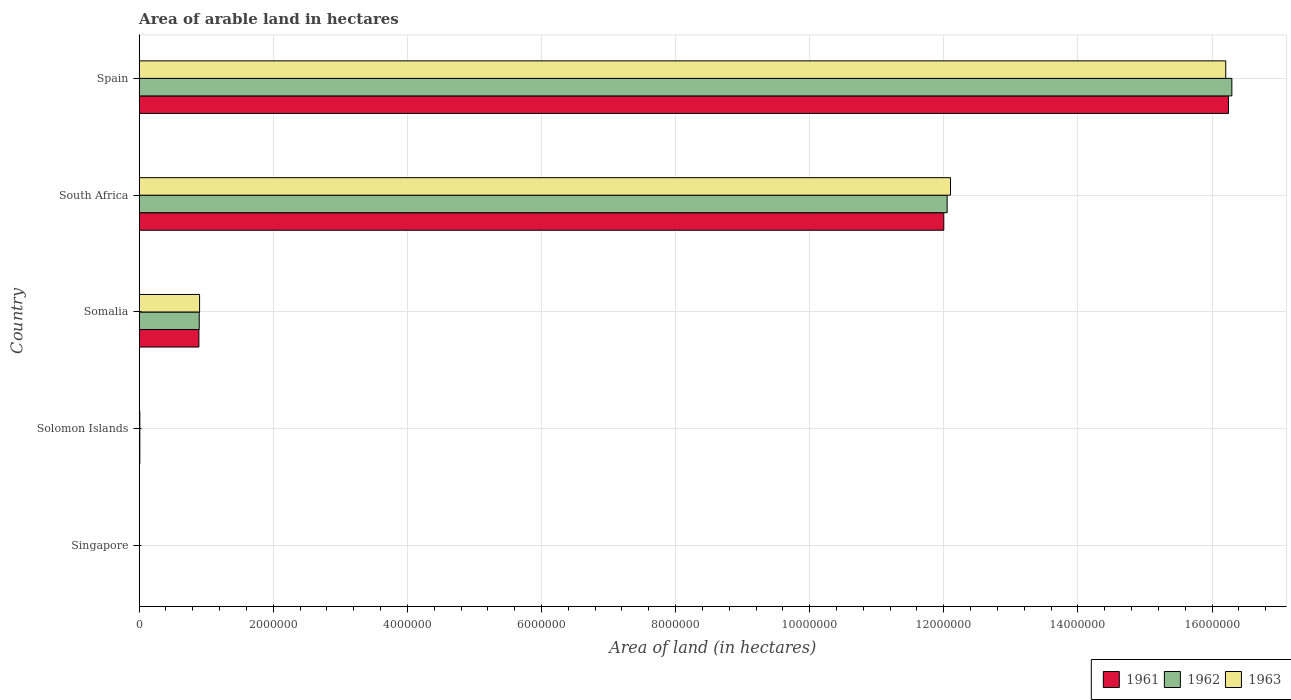How many different coloured bars are there?
Give a very brief answer. 3. How many groups of bars are there?
Your answer should be compact. 5. Are the number of bars on each tick of the Y-axis equal?
Offer a terse response. Yes. How many bars are there on the 3rd tick from the bottom?
Your answer should be very brief. 3. What is the label of the 3rd group of bars from the top?
Make the answer very short. Somalia. In how many cases, is the number of bars for a given country not equal to the number of legend labels?
Keep it short and to the point. 0. What is the total arable land in 1963 in South Africa?
Give a very brief answer. 1.21e+07. Across all countries, what is the maximum total arable land in 1962?
Keep it short and to the point. 1.63e+07. Across all countries, what is the minimum total arable land in 1961?
Offer a terse response. 3000. In which country was the total arable land in 1961 maximum?
Provide a succinct answer. Spain. In which country was the total arable land in 1961 minimum?
Your answer should be very brief. Singapore. What is the total total arable land in 1962 in the graph?
Your response must be concise. 2.93e+07. What is the difference between the total arable land in 1963 in Singapore and that in Somalia?
Provide a succinct answer. -8.97e+05. What is the difference between the total arable land in 1961 in South Africa and the total arable land in 1962 in Somalia?
Your answer should be very brief. 1.11e+07. What is the average total arable land in 1962 per country?
Your response must be concise. 5.85e+06. What is the difference between the total arable land in 1962 and total arable land in 1961 in Singapore?
Offer a terse response. 1000. What is the ratio of the total arable land in 1963 in Solomon Islands to that in Spain?
Your answer should be very brief. 0. Is the total arable land in 1961 in Singapore less than that in South Africa?
Give a very brief answer. Yes. What is the difference between the highest and the second highest total arable land in 1963?
Your response must be concise. 4.10e+06. What is the difference between the highest and the lowest total arable land in 1963?
Your answer should be very brief. 1.62e+07. What does the 2nd bar from the top in Spain represents?
Ensure brevity in your answer.  1962. Is it the case that in every country, the sum of the total arable land in 1963 and total arable land in 1961 is greater than the total arable land in 1962?
Give a very brief answer. Yes. How many bars are there?
Make the answer very short. 15. Does the graph contain grids?
Make the answer very short. Yes. How are the legend labels stacked?
Give a very brief answer. Horizontal. What is the title of the graph?
Provide a succinct answer. Area of arable land in hectares. What is the label or title of the X-axis?
Offer a very short reply. Area of land (in hectares). What is the Area of land (in hectares) of 1961 in Singapore?
Your response must be concise. 3000. What is the Area of land (in hectares) of 1962 in Singapore?
Your response must be concise. 4000. What is the Area of land (in hectares) in 1963 in Singapore?
Keep it short and to the point. 4000. What is the Area of land (in hectares) of 1961 in Somalia?
Your response must be concise. 8.91e+05. What is the Area of land (in hectares) in 1962 in Somalia?
Provide a succinct answer. 8.96e+05. What is the Area of land (in hectares) in 1963 in Somalia?
Provide a short and direct response. 9.01e+05. What is the Area of land (in hectares) in 1962 in South Africa?
Give a very brief answer. 1.20e+07. What is the Area of land (in hectares) of 1963 in South Africa?
Make the answer very short. 1.21e+07. What is the Area of land (in hectares) of 1961 in Spain?
Give a very brief answer. 1.62e+07. What is the Area of land (in hectares) in 1962 in Spain?
Your answer should be very brief. 1.63e+07. What is the Area of land (in hectares) of 1963 in Spain?
Make the answer very short. 1.62e+07. Across all countries, what is the maximum Area of land (in hectares) of 1961?
Give a very brief answer. 1.62e+07. Across all countries, what is the maximum Area of land (in hectares) of 1962?
Keep it short and to the point. 1.63e+07. Across all countries, what is the maximum Area of land (in hectares) in 1963?
Offer a terse response. 1.62e+07. Across all countries, what is the minimum Area of land (in hectares) in 1961?
Your response must be concise. 3000. Across all countries, what is the minimum Area of land (in hectares) of 1962?
Your answer should be compact. 4000. Across all countries, what is the minimum Area of land (in hectares) of 1963?
Provide a succinct answer. 4000. What is the total Area of land (in hectares) of 1961 in the graph?
Ensure brevity in your answer.  2.92e+07. What is the total Area of land (in hectares) of 1962 in the graph?
Offer a very short reply. 2.93e+07. What is the total Area of land (in hectares) in 1963 in the graph?
Provide a short and direct response. 2.92e+07. What is the difference between the Area of land (in hectares) of 1961 in Singapore and that in Solomon Islands?
Give a very brief answer. -7000. What is the difference between the Area of land (in hectares) in 1962 in Singapore and that in Solomon Islands?
Your response must be concise. -6000. What is the difference between the Area of land (in hectares) in 1963 in Singapore and that in Solomon Islands?
Your answer should be compact. -6000. What is the difference between the Area of land (in hectares) in 1961 in Singapore and that in Somalia?
Ensure brevity in your answer.  -8.88e+05. What is the difference between the Area of land (in hectares) of 1962 in Singapore and that in Somalia?
Your answer should be very brief. -8.92e+05. What is the difference between the Area of land (in hectares) of 1963 in Singapore and that in Somalia?
Provide a succinct answer. -8.97e+05. What is the difference between the Area of land (in hectares) in 1961 in Singapore and that in South Africa?
Your response must be concise. -1.20e+07. What is the difference between the Area of land (in hectares) of 1962 in Singapore and that in South Africa?
Ensure brevity in your answer.  -1.20e+07. What is the difference between the Area of land (in hectares) in 1963 in Singapore and that in South Africa?
Your answer should be compact. -1.21e+07. What is the difference between the Area of land (in hectares) of 1961 in Singapore and that in Spain?
Provide a short and direct response. -1.62e+07. What is the difference between the Area of land (in hectares) in 1962 in Singapore and that in Spain?
Your response must be concise. -1.63e+07. What is the difference between the Area of land (in hectares) of 1963 in Singapore and that in Spain?
Your response must be concise. -1.62e+07. What is the difference between the Area of land (in hectares) of 1961 in Solomon Islands and that in Somalia?
Provide a short and direct response. -8.81e+05. What is the difference between the Area of land (in hectares) of 1962 in Solomon Islands and that in Somalia?
Keep it short and to the point. -8.86e+05. What is the difference between the Area of land (in hectares) in 1963 in Solomon Islands and that in Somalia?
Your answer should be compact. -8.91e+05. What is the difference between the Area of land (in hectares) of 1961 in Solomon Islands and that in South Africa?
Keep it short and to the point. -1.20e+07. What is the difference between the Area of land (in hectares) of 1962 in Solomon Islands and that in South Africa?
Offer a very short reply. -1.20e+07. What is the difference between the Area of land (in hectares) of 1963 in Solomon Islands and that in South Africa?
Provide a succinct answer. -1.21e+07. What is the difference between the Area of land (in hectares) of 1961 in Solomon Islands and that in Spain?
Offer a terse response. -1.62e+07. What is the difference between the Area of land (in hectares) in 1962 in Solomon Islands and that in Spain?
Give a very brief answer. -1.63e+07. What is the difference between the Area of land (in hectares) in 1963 in Solomon Islands and that in Spain?
Your response must be concise. -1.62e+07. What is the difference between the Area of land (in hectares) of 1961 in Somalia and that in South Africa?
Make the answer very short. -1.11e+07. What is the difference between the Area of land (in hectares) in 1962 in Somalia and that in South Africa?
Offer a very short reply. -1.12e+07. What is the difference between the Area of land (in hectares) in 1963 in Somalia and that in South Africa?
Make the answer very short. -1.12e+07. What is the difference between the Area of land (in hectares) in 1961 in Somalia and that in Spain?
Provide a succinct answer. -1.54e+07. What is the difference between the Area of land (in hectares) of 1962 in Somalia and that in Spain?
Make the answer very short. -1.54e+07. What is the difference between the Area of land (in hectares) of 1963 in Somalia and that in Spain?
Your answer should be compact. -1.53e+07. What is the difference between the Area of land (in hectares) of 1961 in South Africa and that in Spain?
Keep it short and to the point. -4.25e+06. What is the difference between the Area of land (in hectares) of 1962 in South Africa and that in Spain?
Offer a terse response. -4.25e+06. What is the difference between the Area of land (in hectares) of 1963 in South Africa and that in Spain?
Keep it short and to the point. -4.10e+06. What is the difference between the Area of land (in hectares) of 1961 in Singapore and the Area of land (in hectares) of 1962 in Solomon Islands?
Offer a very short reply. -7000. What is the difference between the Area of land (in hectares) in 1961 in Singapore and the Area of land (in hectares) in 1963 in Solomon Islands?
Your response must be concise. -7000. What is the difference between the Area of land (in hectares) in 1962 in Singapore and the Area of land (in hectares) in 1963 in Solomon Islands?
Your response must be concise. -6000. What is the difference between the Area of land (in hectares) in 1961 in Singapore and the Area of land (in hectares) in 1962 in Somalia?
Ensure brevity in your answer.  -8.93e+05. What is the difference between the Area of land (in hectares) in 1961 in Singapore and the Area of land (in hectares) in 1963 in Somalia?
Offer a terse response. -8.98e+05. What is the difference between the Area of land (in hectares) in 1962 in Singapore and the Area of land (in hectares) in 1963 in Somalia?
Your answer should be compact. -8.97e+05. What is the difference between the Area of land (in hectares) of 1961 in Singapore and the Area of land (in hectares) of 1962 in South Africa?
Provide a short and direct response. -1.20e+07. What is the difference between the Area of land (in hectares) in 1961 in Singapore and the Area of land (in hectares) in 1963 in South Africa?
Your response must be concise. -1.21e+07. What is the difference between the Area of land (in hectares) in 1962 in Singapore and the Area of land (in hectares) in 1963 in South Africa?
Provide a succinct answer. -1.21e+07. What is the difference between the Area of land (in hectares) in 1961 in Singapore and the Area of land (in hectares) in 1962 in Spain?
Ensure brevity in your answer.  -1.63e+07. What is the difference between the Area of land (in hectares) of 1961 in Singapore and the Area of land (in hectares) of 1963 in Spain?
Give a very brief answer. -1.62e+07. What is the difference between the Area of land (in hectares) in 1962 in Singapore and the Area of land (in hectares) in 1963 in Spain?
Make the answer very short. -1.62e+07. What is the difference between the Area of land (in hectares) of 1961 in Solomon Islands and the Area of land (in hectares) of 1962 in Somalia?
Ensure brevity in your answer.  -8.86e+05. What is the difference between the Area of land (in hectares) of 1961 in Solomon Islands and the Area of land (in hectares) of 1963 in Somalia?
Offer a terse response. -8.91e+05. What is the difference between the Area of land (in hectares) in 1962 in Solomon Islands and the Area of land (in hectares) in 1963 in Somalia?
Your answer should be very brief. -8.91e+05. What is the difference between the Area of land (in hectares) of 1961 in Solomon Islands and the Area of land (in hectares) of 1962 in South Africa?
Provide a short and direct response. -1.20e+07. What is the difference between the Area of land (in hectares) of 1961 in Solomon Islands and the Area of land (in hectares) of 1963 in South Africa?
Your answer should be very brief. -1.21e+07. What is the difference between the Area of land (in hectares) in 1962 in Solomon Islands and the Area of land (in hectares) in 1963 in South Africa?
Provide a succinct answer. -1.21e+07. What is the difference between the Area of land (in hectares) in 1961 in Solomon Islands and the Area of land (in hectares) in 1962 in Spain?
Offer a very short reply. -1.63e+07. What is the difference between the Area of land (in hectares) of 1961 in Solomon Islands and the Area of land (in hectares) of 1963 in Spain?
Your answer should be very brief. -1.62e+07. What is the difference between the Area of land (in hectares) in 1962 in Solomon Islands and the Area of land (in hectares) in 1963 in Spain?
Keep it short and to the point. -1.62e+07. What is the difference between the Area of land (in hectares) in 1961 in Somalia and the Area of land (in hectares) in 1962 in South Africa?
Give a very brief answer. -1.12e+07. What is the difference between the Area of land (in hectares) of 1961 in Somalia and the Area of land (in hectares) of 1963 in South Africa?
Provide a succinct answer. -1.12e+07. What is the difference between the Area of land (in hectares) in 1962 in Somalia and the Area of land (in hectares) in 1963 in South Africa?
Provide a succinct answer. -1.12e+07. What is the difference between the Area of land (in hectares) in 1961 in Somalia and the Area of land (in hectares) in 1962 in Spain?
Your answer should be very brief. -1.54e+07. What is the difference between the Area of land (in hectares) in 1961 in Somalia and the Area of land (in hectares) in 1963 in Spain?
Your answer should be compact. -1.53e+07. What is the difference between the Area of land (in hectares) in 1962 in Somalia and the Area of land (in hectares) in 1963 in Spain?
Keep it short and to the point. -1.53e+07. What is the difference between the Area of land (in hectares) of 1961 in South Africa and the Area of land (in hectares) of 1962 in Spain?
Offer a very short reply. -4.30e+06. What is the difference between the Area of land (in hectares) in 1961 in South Africa and the Area of land (in hectares) in 1963 in Spain?
Make the answer very short. -4.20e+06. What is the difference between the Area of land (in hectares) of 1962 in South Africa and the Area of land (in hectares) of 1963 in Spain?
Your answer should be very brief. -4.16e+06. What is the average Area of land (in hectares) in 1961 per country?
Keep it short and to the point. 5.83e+06. What is the average Area of land (in hectares) in 1962 per country?
Make the answer very short. 5.85e+06. What is the average Area of land (in hectares) in 1963 per country?
Your answer should be very brief. 5.84e+06. What is the difference between the Area of land (in hectares) in 1961 and Area of land (in hectares) in 1962 in Singapore?
Offer a very short reply. -1000. What is the difference between the Area of land (in hectares) of 1961 and Area of land (in hectares) of 1963 in Singapore?
Ensure brevity in your answer.  -1000. What is the difference between the Area of land (in hectares) of 1961 and Area of land (in hectares) of 1963 in Solomon Islands?
Provide a short and direct response. 0. What is the difference between the Area of land (in hectares) in 1962 and Area of land (in hectares) in 1963 in Solomon Islands?
Give a very brief answer. 0. What is the difference between the Area of land (in hectares) in 1961 and Area of land (in hectares) in 1962 in Somalia?
Give a very brief answer. -5000. What is the difference between the Area of land (in hectares) in 1961 and Area of land (in hectares) in 1963 in Somalia?
Offer a very short reply. -10000. What is the difference between the Area of land (in hectares) of 1962 and Area of land (in hectares) of 1963 in Somalia?
Offer a terse response. -5000. What is the difference between the Area of land (in hectares) in 1961 and Area of land (in hectares) in 1962 in South Africa?
Your response must be concise. -5.00e+04. What is the difference between the Area of land (in hectares) in 1961 and Area of land (in hectares) in 1963 in South Africa?
Make the answer very short. -1.00e+05. What is the difference between the Area of land (in hectares) of 1961 and Area of land (in hectares) of 1963 in Spain?
Ensure brevity in your answer.  4.10e+04. What is the difference between the Area of land (in hectares) in 1962 and Area of land (in hectares) in 1963 in Spain?
Provide a short and direct response. 9.10e+04. What is the ratio of the Area of land (in hectares) of 1962 in Singapore to that in Solomon Islands?
Ensure brevity in your answer.  0.4. What is the ratio of the Area of land (in hectares) of 1963 in Singapore to that in Solomon Islands?
Keep it short and to the point. 0.4. What is the ratio of the Area of land (in hectares) in 1961 in Singapore to that in Somalia?
Provide a short and direct response. 0. What is the ratio of the Area of land (in hectares) in 1962 in Singapore to that in Somalia?
Provide a short and direct response. 0. What is the ratio of the Area of land (in hectares) of 1963 in Singapore to that in Somalia?
Provide a short and direct response. 0. What is the ratio of the Area of land (in hectares) in 1961 in Singapore to that in South Africa?
Offer a terse response. 0. What is the ratio of the Area of land (in hectares) of 1962 in Singapore to that in South Africa?
Keep it short and to the point. 0. What is the ratio of the Area of land (in hectares) of 1961 in Singapore to that in Spain?
Provide a short and direct response. 0. What is the ratio of the Area of land (in hectares) of 1962 in Singapore to that in Spain?
Your answer should be compact. 0. What is the ratio of the Area of land (in hectares) in 1961 in Solomon Islands to that in Somalia?
Provide a short and direct response. 0.01. What is the ratio of the Area of land (in hectares) of 1962 in Solomon Islands to that in Somalia?
Your answer should be very brief. 0.01. What is the ratio of the Area of land (in hectares) in 1963 in Solomon Islands to that in Somalia?
Provide a short and direct response. 0.01. What is the ratio of the Area of land (in hectares) of 1961 in Solomon Islands to that in South Africa?
Provide a short and direct response. 0. What is the ratio of the Area of land (in hectares) in 1962 in Solomon Islands to that in South Africa?
Provide a short and direct response. 0. What is the ratio of the Area of land (in hectares) of 1963 in Solomon Islands to that in South Africa?
Provide a succinct answer. 0. What is the ratio of the Area of land (in hectares) of 1961 in Solomon Islands to that in Spain?
Your response must be concise. 0. What is the ratio of the Area of land (in hectares) of 1962 in Solomon Islands to that in Spain?
Give a very brief answer. 0. What is the ratio of the Area of land (in hectares) of 1963 in Solomon Islands to that in Spain?
Keep it short and to the point. 0. What is the ratio of the Area of land (in hectares) of 1961 in Somalia to that in South Africa?
Make the answer very short. 0.07. What is the ratio of the Area of land (in hectares) of 1962 in Somalia to that in South Africa?
Provide a short and direct response. 0.07. What is the ratio of the Area of land (in hectares) of 1963 in Somalia to that in South Africa?
Provide a succinct answer. 0.07. What is the ratio of the Area of land (in hectares) of 1961 in Somalia to that in Spain?
Your response must be concise. 0.05. What is the ratio of the Area of land (in hectares) of 1962 in Somalia to that in Spain?
Keep it short and to the point. 0.06. What is the ratio of the Area of land (in hectares) in 1963 in Somalia to that in Spain?
Your answer should be compact. 0.06. What is the ratio of the Area of land (in hectares) of 1961 in South Africa to that in Spain?
Keep it short and to the point. 0.74. What is the ratio of the Area of land (in hectares) in 1962 in South Africa to that in Spain?
Offer a very short reply. 0.74. What is the ratio of the Area of land (in hectares) in 1963 in South Africa to that in Spain?
Offer a very short reply. 0.75. What is the difference between the highest and the second highest Area of land (in hectares) in 1961?
Make the answer very short. 4.25e+06. What is the difference between the highest and the second highest Area of land (in hectares) of 1962?
Ensure brevity in your answer.  4.25e+06. What is the difference between the highest and the second highest Area of land (in hectares) of 1963?
Give a very brief answer. 4.10e+06. What is the difference between the highest and the lowest Area of land (in hectares) in 1961?
Provide a succinct answer. 1.62e+07. What is the difference between the highest and the lowest Area of land (in hectares) of 1962?
Offer a very short reply. 1.63e+07. What is the difference between the highest and the lowest Area of land (in hectares) of 1963?
Your answer should be very brief. 1.62e+07. 